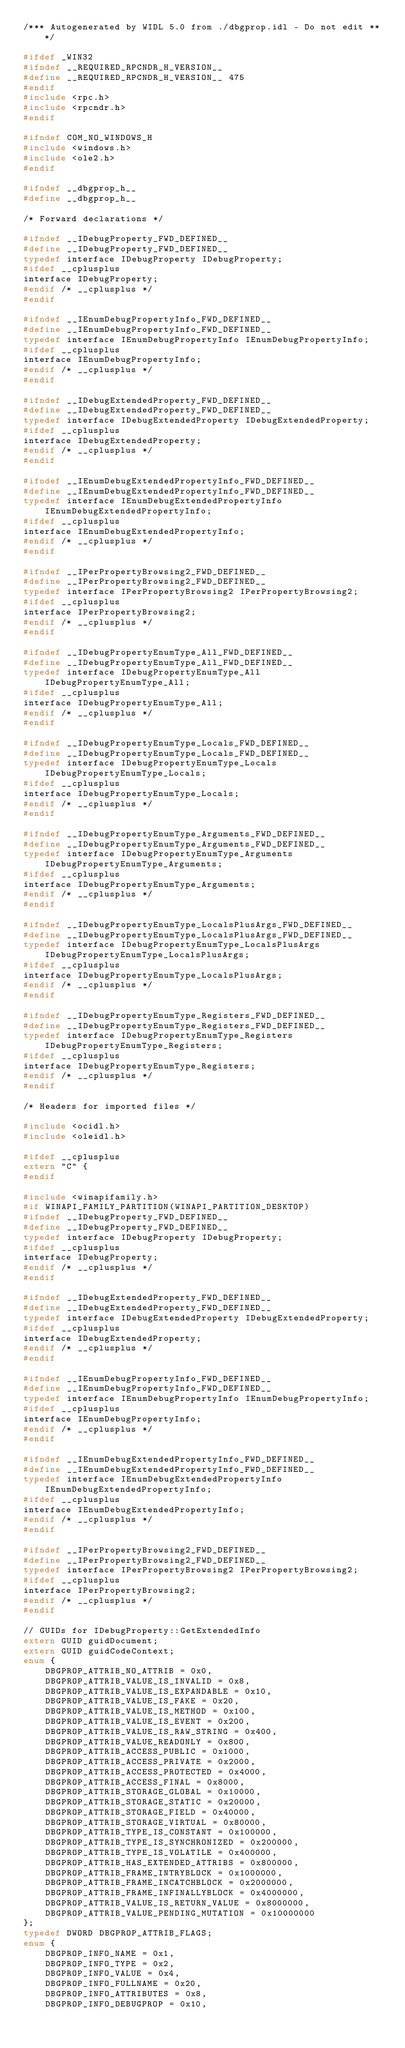Convert code to text. <code><loc_0><loc_0><loc_500><loc_500><_C_>/*** Autogenerated by WIDL 5.0 from ./dbgprop.idl - Do not edit ***/

#ifdef _WIN32
#ifndef __REQUIRED_RPCNDR_H_VERSION__
#define __REQUIRED_RPCNDR_H_VERSION__ 475
#endif
#include <rpc.h>
#include <rpcndr.h>
#endif

#ifndef COM_NO_WINDOWS_H
#include <windows.h>
#include <ole2.h>
#endif

#ifndef __dbgprop_h__
#define __dbgprop_h__

/* Forward declarations */

#ifndef __IDebugProperty_FWD_DEFINED__
#define __IDebugProperty_FWD_DEFINED__
typedef interface IDebugProperty IDebugProperty;
#ifdef __cplusplus
interface IDebugProperty;
#endif /* __cplusplus */
#endif

#ifndef __IEnumDebugPropertyInfo_FWD_DEFINED__
#define __IEnumDebugPropertyInfo_FWD_DEFINED__
typedef interface IEnumDebugPropertyInfo IEnumDebugPropertyInfo;
#ifdef __cplusplus
interface IEnumDebugPropertyInfo;
#endif /* __cplusplus */
#endif

#ifndef __IDebugExtendedProperty_FWD_DEFINED__
#define __IDebugExtendedProperty_FWD_DEFINED__
typedef interface IDebugExtendedProperty IDebugExtendedProperty;
#ifdef __cplusplus
interface IDebugExtendedProperty;
#endif /* __cplusplus */
#endif

#ifndef __IEnumDebugExtendedPropertyInfo_FWD_DEFINED__
#define __IEnumDebugExtendedPropertyInfo_FWD_DEFINED__
typedef interface IEnumDebugExtendedPropertyInfo IEnumDebugExtendedPropertyInfo;
#ifdef __cplusplus
interface IEnumDebugExtendedPropertyInfo;
#endif /* __cplusplus */
#endif

#ifndef __IPerPropertyBrowsing2_FWD_DEFINED__
#define __IPerPropertyBrowsing2_FWD_DEFINED__
typedef interface IPerPropertyBrowsing2 IPerPropertyBrowsing2;
#ifdef __cplusplus
interface IPerPropertyBrowsing2;
#endif /* __cplusplus */
#endif

#ifndef __IDebugPropertyEnumType_All_FWD_DEFINED__
#define __IDebugPropertyEnumType_All_FWD_DEFINED__
typedef interface IDebugPropertyEnumType_All IDebugPropertyEnumType_All;
#ifdef __cplusplus
interface IDebugPropertyEnumType_All;
#endif /* __cplusplus */
#endif

#ifndef __IDebugPropertyEnumType_Locals_FWD_DEFINED__
#define __IDebugPropertyEnumType_Locals_FWD_DEFINED__
typedef interface IDebugPropertyEnumType_Locals IDebugPropertyEnumType_Locals;
#ifdef __cplusplus
interface IDebugPropertyEnumType_Locals;
#endif /* __cplusplus */
#endif

#ifndef __IDebugPropertyEnumType_Arguments_FWD_DEFINED__
#define __IDebugPropertyEnumType_Arguments_FWD_DEFINED__
typedef interface IDebugPropertyEnumType_Arguments IDebugPropertyEnumType_Arguments;
#ifdef __cplusplus
interface IDebugPropertyEnumType_Arguments;
#endif /* __cplusplus */
#endif

#ifndef __IDebugPropertyEnumType_LocalsPlusArgs_FWD_DEFINED__
#define __IDebugPropertyEnumType_LocalsPlusArgs_FWD_DEFINED__
typedef interface IDebugPropertyEnumType_LocalsPlusArgs IDebugPropertyEnumType_LocalsPlusArgs;
#ifdef __cplusplus
interface IDebugPropertyEnumType_LocalsPlusArgs;
#endif /* __cplusplus */
#endif

#ifndef __IDebugPropertyEnumType_Registers_FWD_DEFINED__
#define __IDebugPropertyEnumType_Registers_FWD_DEFINED__
typedef interface IDebugPropertyEnumType_Registers IDebugPropertyEnumType_Registers;
#ifdef __cplusplus
interface IDebugPropertyEnumType_Registers;
#endif /* __cplusplus */
#endif

/* Headers for imported files */

#include <ocidl.h>
#include <oleidl.h>

#ifdef __cplusplus
extern "C" {
#endif

#include <winapifamily.h>
#if WINAPI_FAMILY_PARTITION(WINAPI_PARTITION_DESKTOP)
#ifndef __IDebugProperty_FWD_DEFINED__
#define __IDebugProperty_FWD_DEFINED__
typedef interface IDebugProperty IDebugProperty;
#ifdef __cplusplus
interface IDebugProperty;
#endif /* __cplusplus */
#endif

#ifndef __IDebugExtendedProperty_FWD_DEFINED__
#define __IDebugExtendedProperty_FWD_DEFINED__
typedef interface IDebugExtendedProperty IDebugExtendedProperty;
#ifdef __cplusplus
interface IDebugExtendedProperty;
#endif /* __cplusplus */
#endif

#ifndef __IEnumDebugPropertyInfo_FWD_DEFINED__
#define __IEnumDebugPropertyInfo_FWD_DEFINED__
typedef interface IEnumDebugPropertyInfo IEnumDebugPropertyInfo;
#ifdef __cplusplus
interface IEnumDebugPropertyInfo;
#endif /* __cplusplus */
#endif

#ifndef __IEnumDebugExtendedPropertyInfo_FWD_DEFINED__
#define __IEnumDebugExtendedPropertyInfo_FWD_DEFINED__
typedef interface IEnumDebugExtendedPropertyInfo IEnumDebugExtendedPropertyInfo;
#ifdef __cplusplus
interface IEnumDebugExtendedPropertyInfo;
#endif /* __cplusplus */
#endif

#ifndef __IPerPropertyBrowsing2_FWD_DEFINED__
#define __IPerPropertyBrowsing2_FWD_DEFINED__
typedef interface IPerPropertyBrowsing2 IPerPropertyBrowsing2;
#ifdef __cplusplus
interface IPerPropertyBrowsing2;
#endif /* __cplusplus */
#endif

// GUIDs for IDebugProperty::GetExtendedInfo
extern GUID guidDocument;
extern GUID guidCodeContext;
enum {
    DBGPROP_ATTRIB_NO_ATTRIB = 0x0,
    DBGPROP_ATTRIB_VALUE_IS_INVALID = 0x8,
    DBGPROP_ATTRIB_VALUE_IS_EXPANDABLE = 0x10,
    DBGPROP_ATTRIB_VALUE_IS_FAKE = 0x20,
    DBGPROP_ATTRIB_VALUE_IS_METHOD = 0x100,
    DBGPROP_ATTRIB_VALUE_IS_EVENT = 0x200,
    DBGPROP_ATTRIB_VALUE_IS_RAW_STRING = 0x400,
    DBGPROP_ATTRIB_VALUE_READONLY = 0x800,
    DBGPROP_ATTRIB_ACCESS_PUBLIC = 0x1000,
    DBGPROP_ATTRIB_ACCESS_PRIVATE = 0x2000,
    DBGPROP_ATTRIB_ACCESS_PROTECTED = 0x4000,
    DBGPROP_ATTRIB_ACCESS_FINAL = 0x8000,
    DBGPROP_ATTRIB_STORAGE_GLOBAL = 0x10000,
    DBGPROP_ATTRIB_STORAGE_STATIC = 0x20000,
    DBGPROP_ATTRIB_STORAGE_FIELD = 0x40000,
    DBGPROP_ATTRIB_STORAGE_VIRTUAL = 0x80000,
    DBGPROP_ATTRIB_TYPE_IS_CONSTANT = 0x100000,
    DBGPROP_ATTRIB_TYPE_IS_SYNCHRONIZED = 0x200000,
    DBGPROP_ATTRIB_TYPE_IS_VOLATILE = 0x400000,
    DBGPROP_ATTRIB_HAS_EXTENDED_ATTRIBS = 0x800000,
    DBGPROP_ATTRIB_FRAME_INTRYBLOCK = 0x1000000,
    DBGPROP_ATTRIB_FRAME_INCATCHBLOCK = 0x2000000,
    DBGPROP_ATTRIB_FRAME_INFINALLYBLOCK = 0x4000000,
    DBGPROP_ATTRIB_VALUE_IS_RETURN_VALUE = 0x8000000,
    DBGPROP_ATTRIB_VALUE_PENDING_MUTATION = 0x10000000
};
typedef DWORD DBGPROP_ATTRIB_FLAGS;
enum {
    DBGPROP_INFO_NAME = 0x1,
    DBGPROP_INFO_TYPE = 0x2,
    DBGPROP_INFO_VALUE = 0x4,
    DBGPROP_INFO_FULLNAME = 0x20,
    DBGPROP_INFO_ATTRIBUTES = 0x8,
    DBGPROP_INFO_DEBUGPROP = 0x10,</code> 